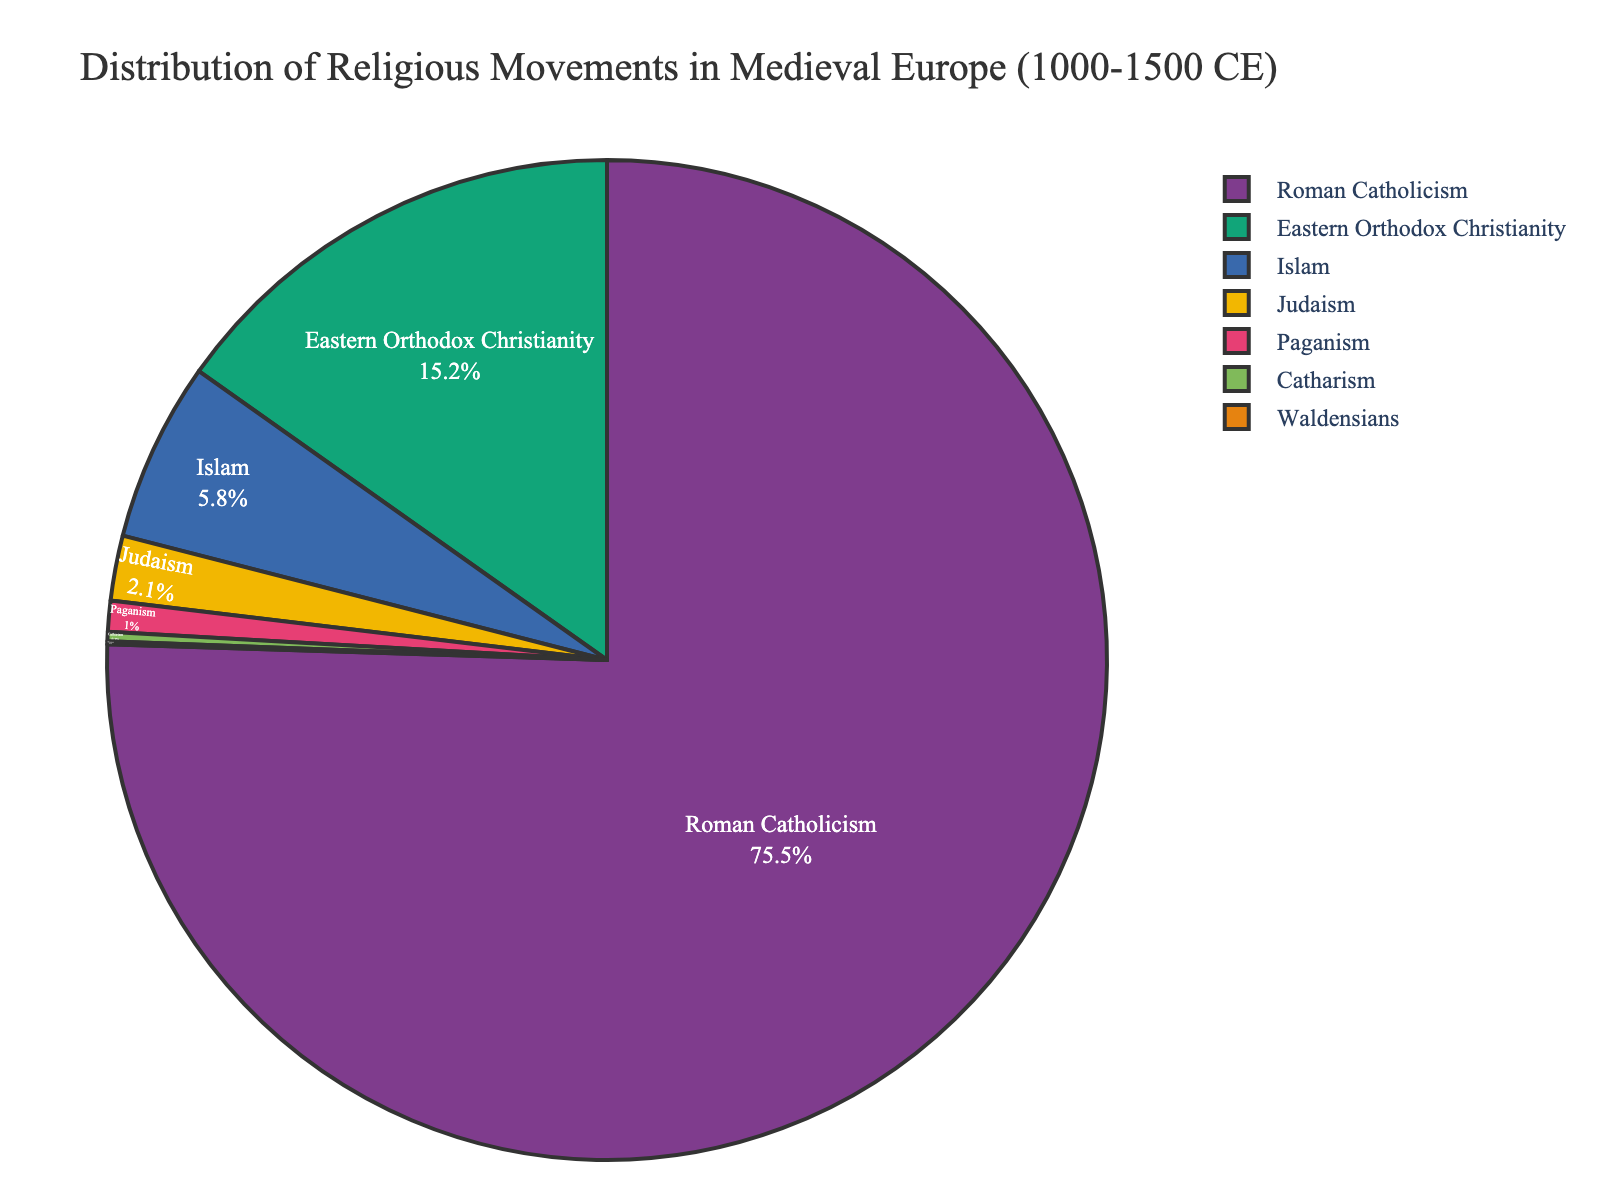What percentage of the population practiced Roman Catholicism? The pie chart shows that Roman Catholicism is represented by 75.5%.
Answer: 75.5% Which religion had the second highest percentage? From the pie chart, the second largest portion is for Eastern Orthodox Christianity with 15.2%.
Answer: Eastern Orthodox Christianity How does the percentage of Judaism compare to Paganism? The pie chart shows Judaism at 2.1% and Paganism at 1.0%. Thus, Judaism is more than double the percentage of Paganism.
Answer: Judaism is more than double Paganism What is the combined percentage of religions other than Roman Catholicism and Eastern Orthodox Christianity? Adding the percentages for Islam (5.8), Judaism (2.1), Paganism (1.0), Catharism (0.3), and Waldensians (0.1) sums to 9.3%.
Answer: 9.3% Which religion occupies the smallest proportion in the pie chart? The pie chart indicates that Waldensians have the smallest portion at 0.1%.
Answer: Waldensians If you combine the percentages of all Christian denominations, what is the total percentage? Adding Roman Catholicism (75.5%) and Eastern Orthodox Christianity (15.2%) gives a total of 90.7%.
Answer: 90.7% Visually, how does the segment for Islam compare in size to that of Paganism? The segment for Islam appears significantly larger than the segment for Paganism in the pie chart.
Answer: Islam is larger than Paganism What percentage of the population followed minority religions (percentage less than 5%)? Adding Islam (5.8), Judaism (2.1), Paganism (1.0), Catharism (0.3), and Waldensians (0.1) results in a combined percentage of 9.3%. Subtracting Islam's 5.8%, the remaining is 3.5%.
Answer: 3.5% What is the difference between the percentages of Roman Catholicism and Eastern Orthodox Christianity? The difference is calculated as 75.5% for Roman Catholicism minus 15.2% for Eastern Orthodox Christianity, resulting in a difference of 60.3%.
Answer: 60.3% 